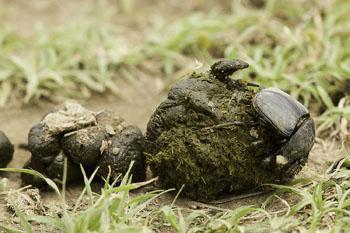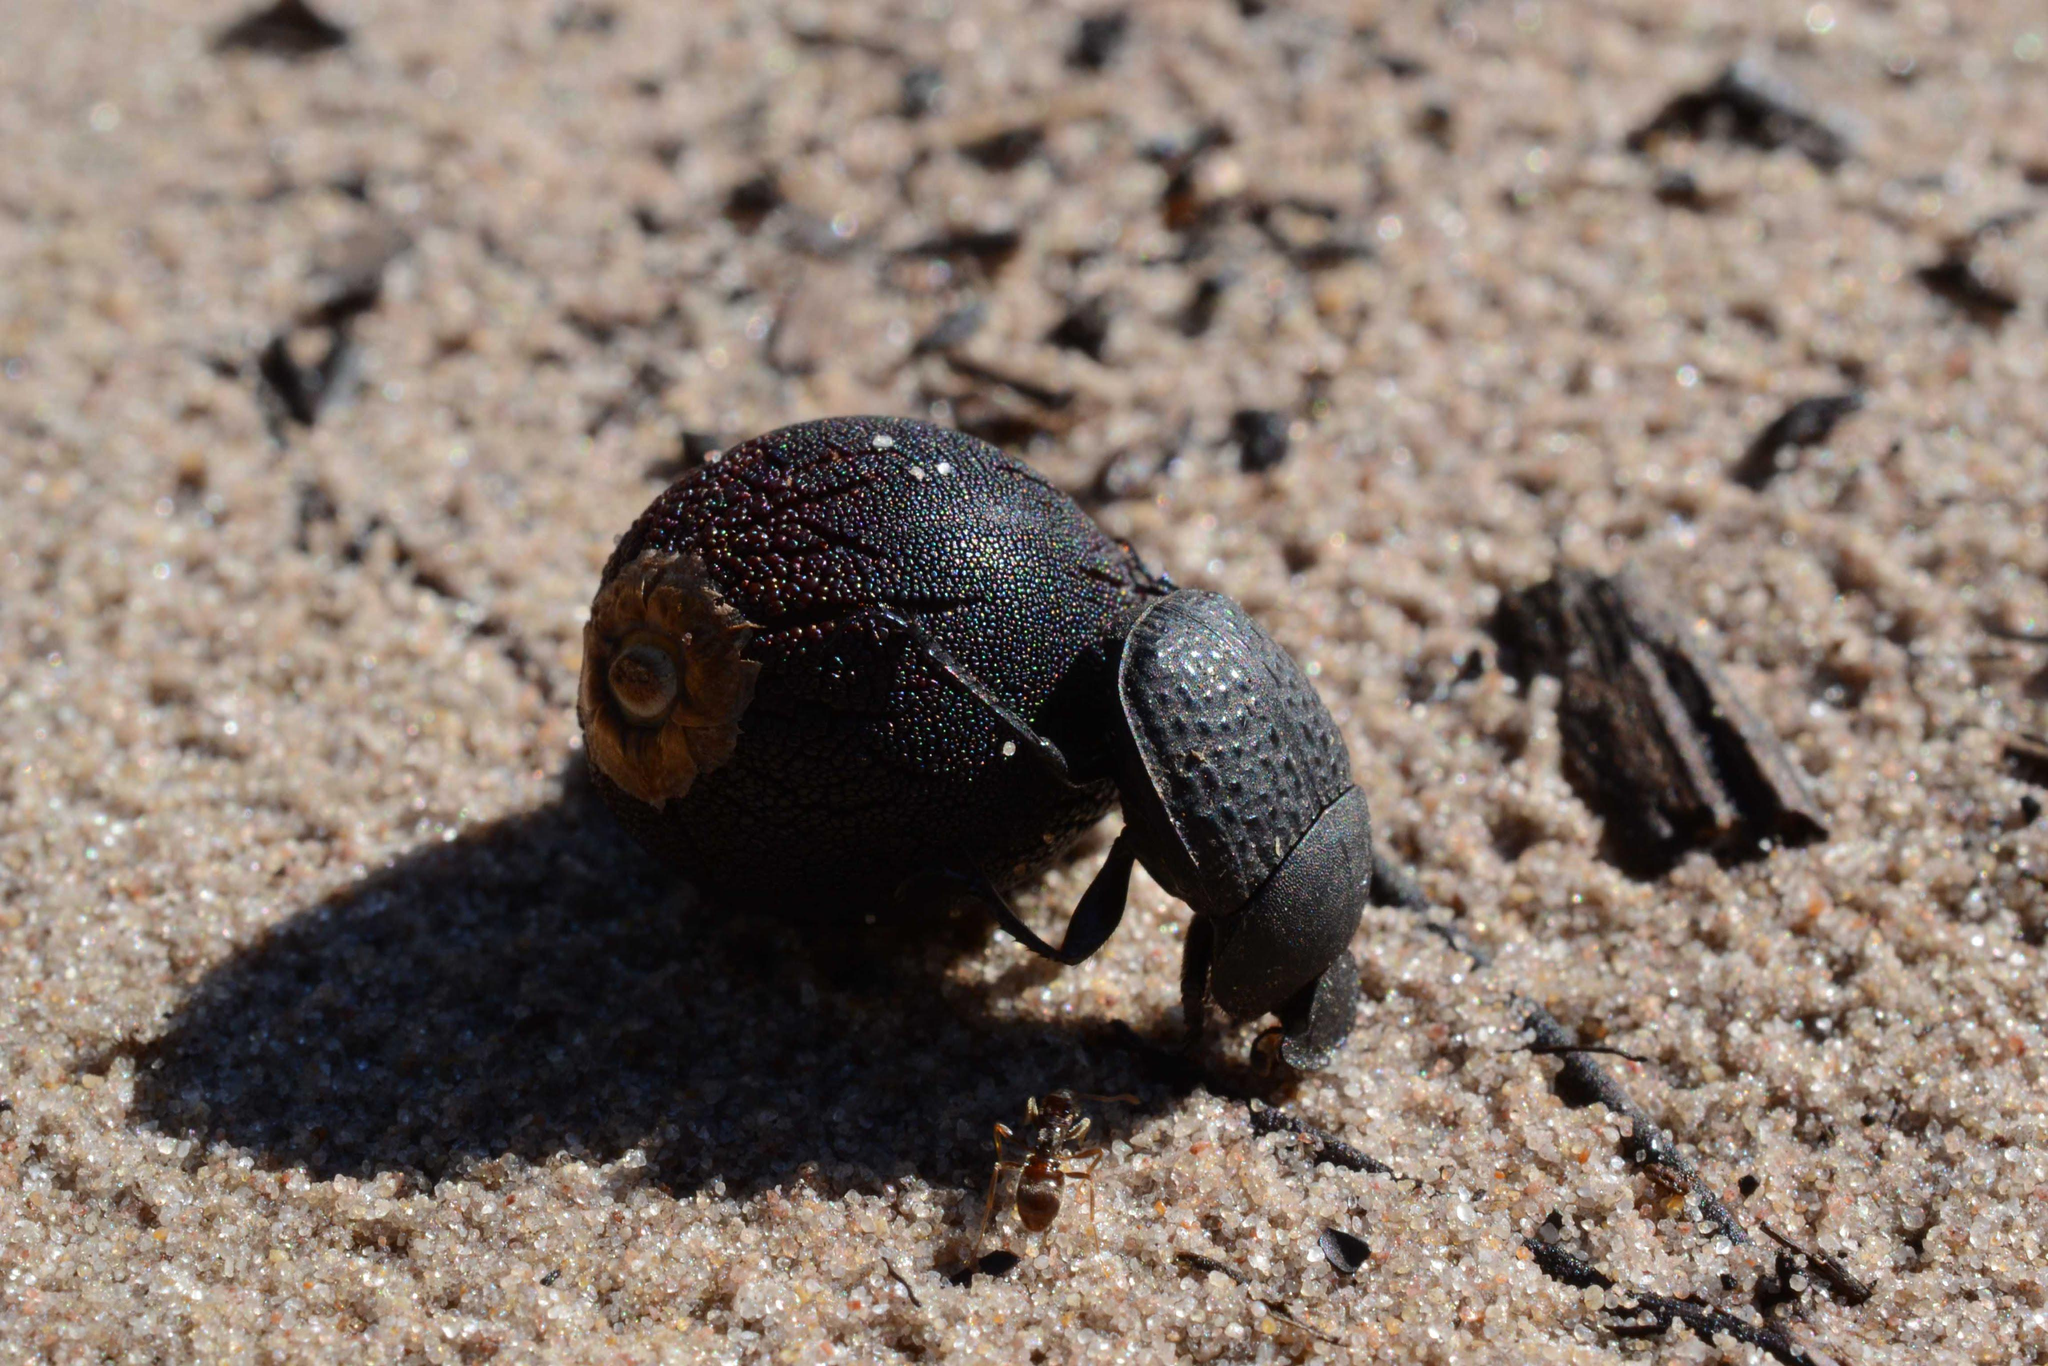The first image is the image on the left, the second image is the image on the right. Evaluate the accuracy of this statement regarding the images: "A beetle with a shiny textured back is alone in an image without a dung ball shape.". Is it true? Answer yes or no. No. 